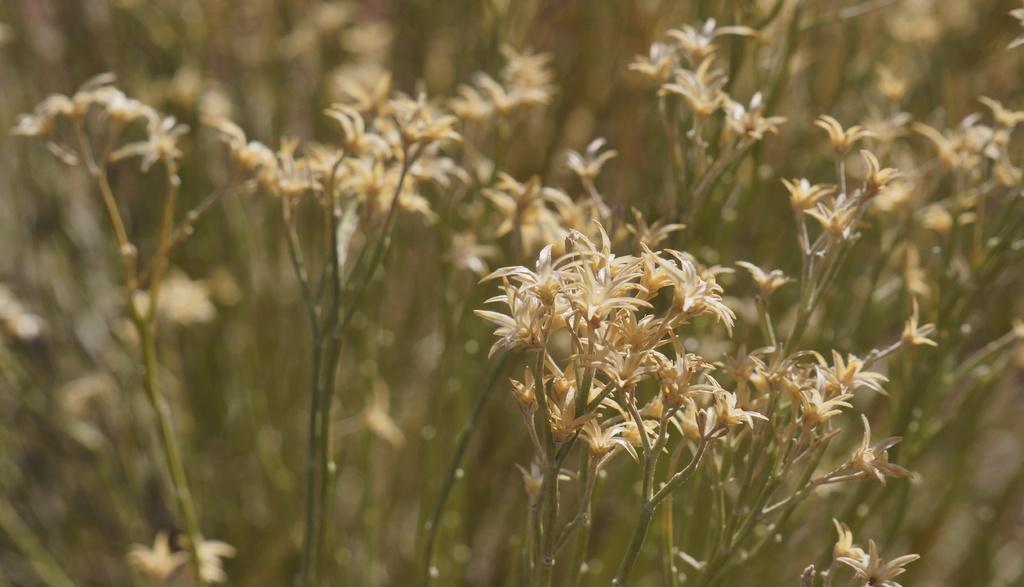What is present in the image? There are flowers in the image. Can you describe the background of the image? The background of the image is blurry. What is the weight of the baby in the image? There is no baby present in the image, so it is not possible to determine the weight of a baby. 